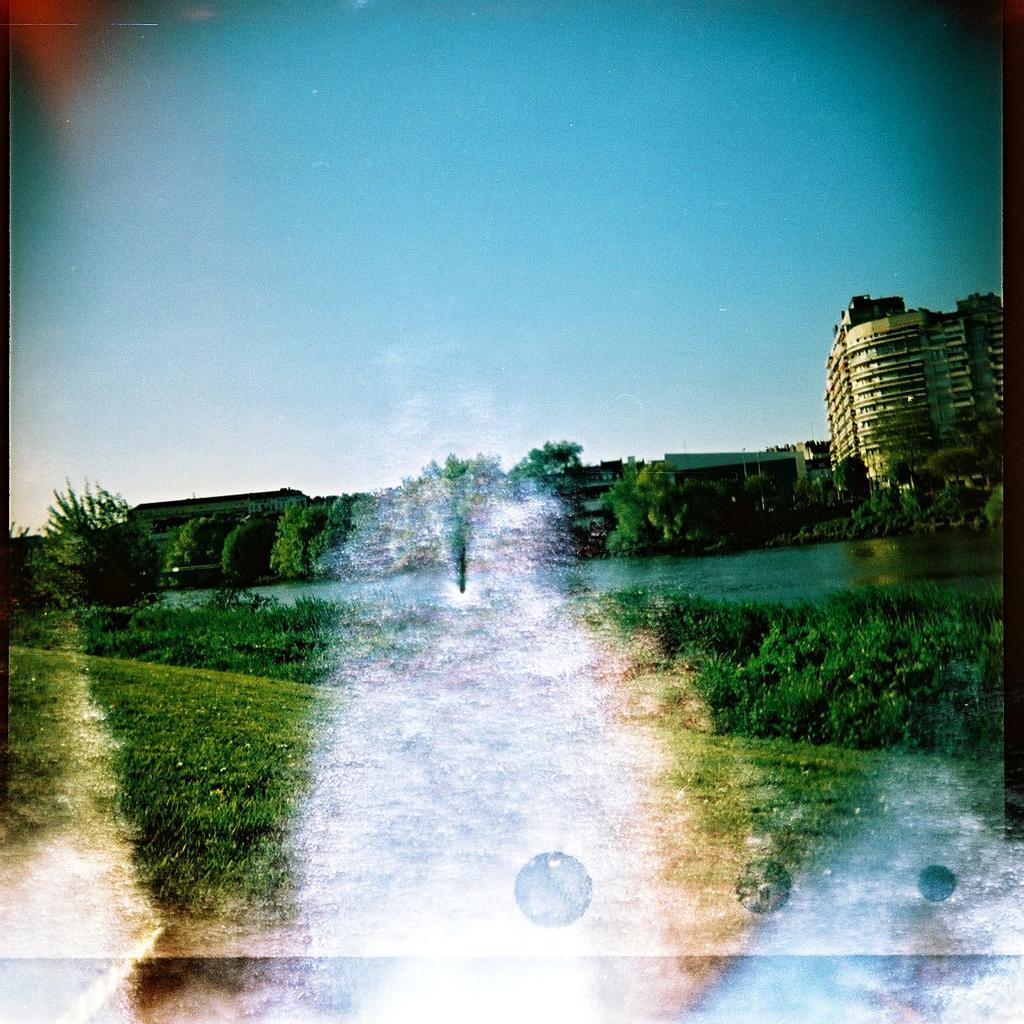How would you summarize this image in a sentence or two? In the picture we can see a photograph of a grass surface with some plants and behind it, we can see water and far away from it, we can see some trees and beside it, we can see a tower building with many floors and behind it we can see a sky with clouds. 